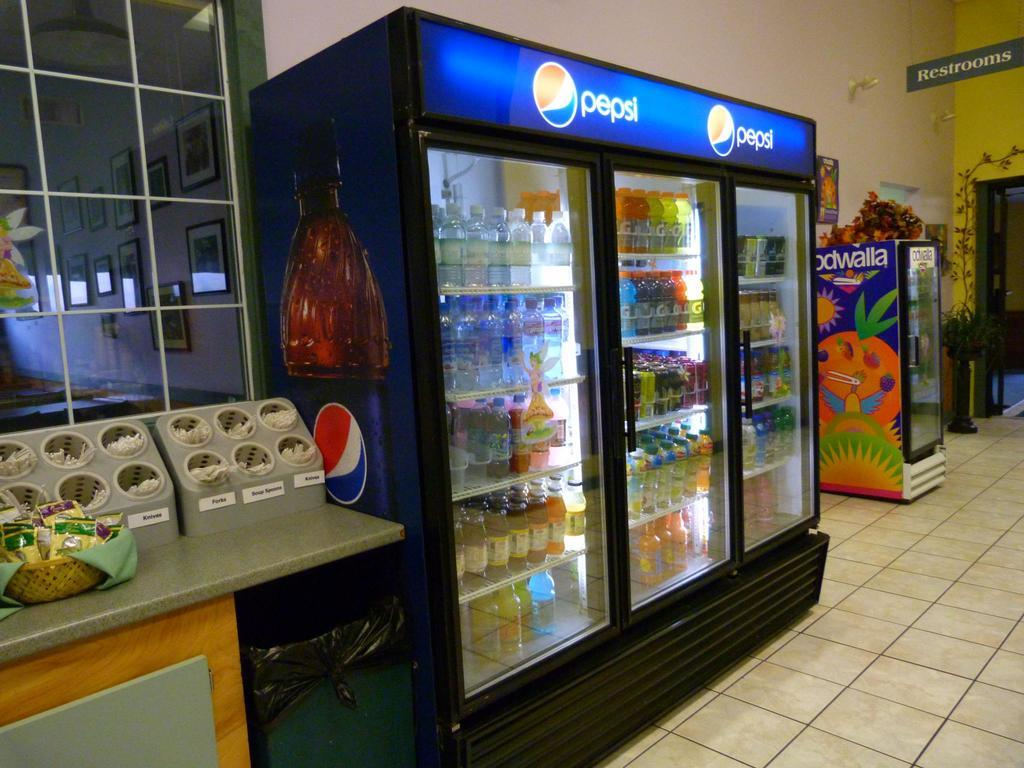<image>
Create a compact narrative representing the image presented. A cooler in a store that has beverages in it next to a sign for the restrooms. 